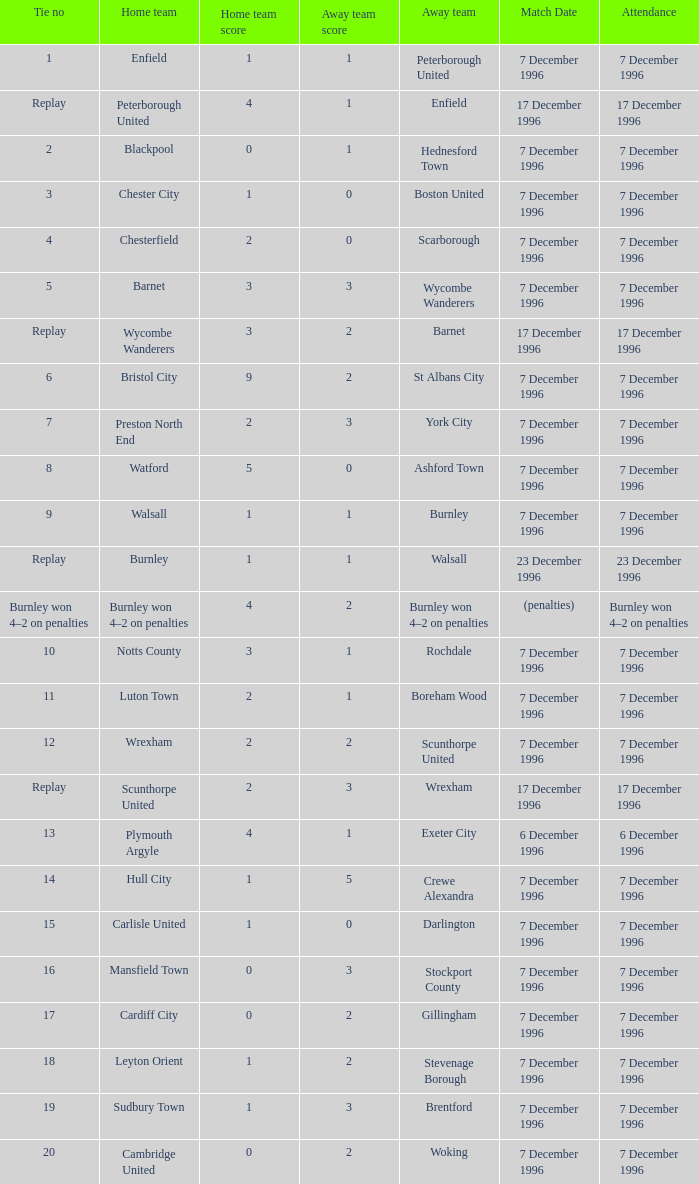What was the score of tie number 15? 1–0. 